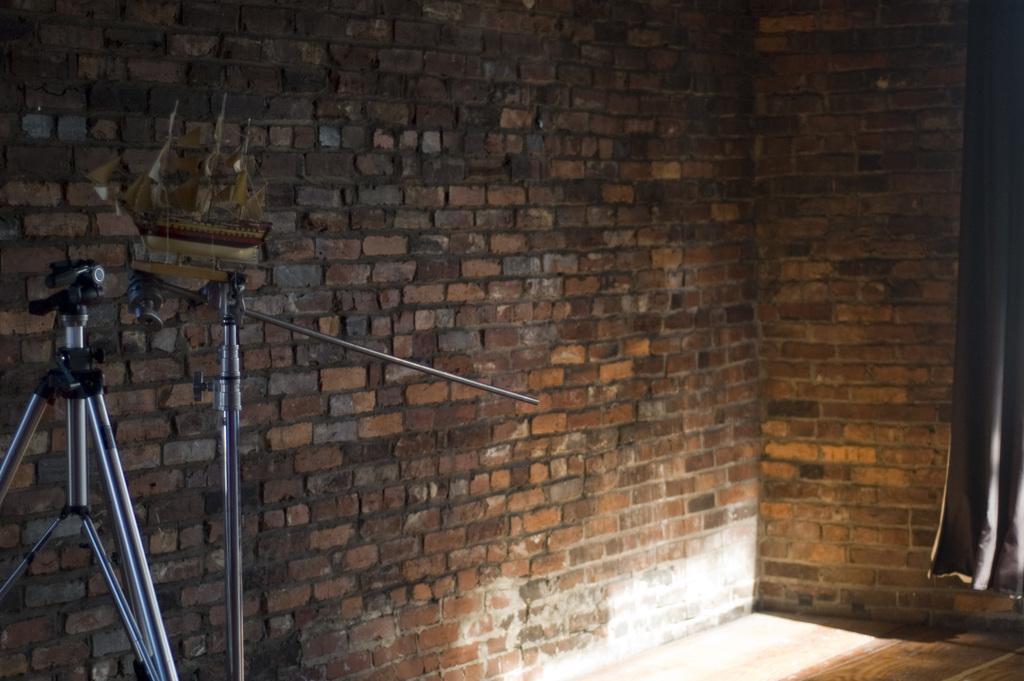Describe this image in one or two sentences. In this image we can see a camera, stands, a brick wall, also we can see a curtain. 